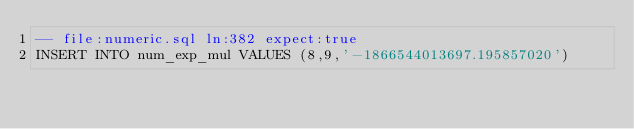Convert code to text. <code><loc_0><loc_0><loc_500><loc_500><_SQL_>-- file:numeric.sql ln:382 expect:true
INSERT INTO num_exp_mul VALUES (8,9,'-1866544013697.195857020')
</code> 